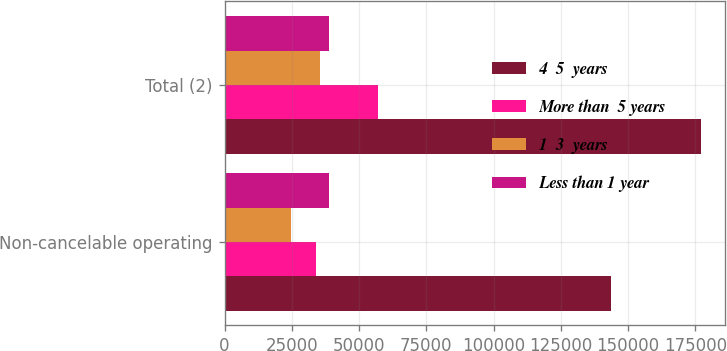Convert chart. <chart><loc_0><loc_0><loc_500><loc_500><stacked_bar_chart><ecel><fcel>Non-cancelable operating<fcel>Total (2)<nl><fcel>4  5  years<fcel>143539<fcel>177012<nl><fcel>More than  5 years<fcel>34112<fcel>56857<nl><fcel>1  3  years<fcel>24890<fcel>35618<nl><fcel>Less than 1 year<fcel>38713<fcel>38713<nl></chart> 